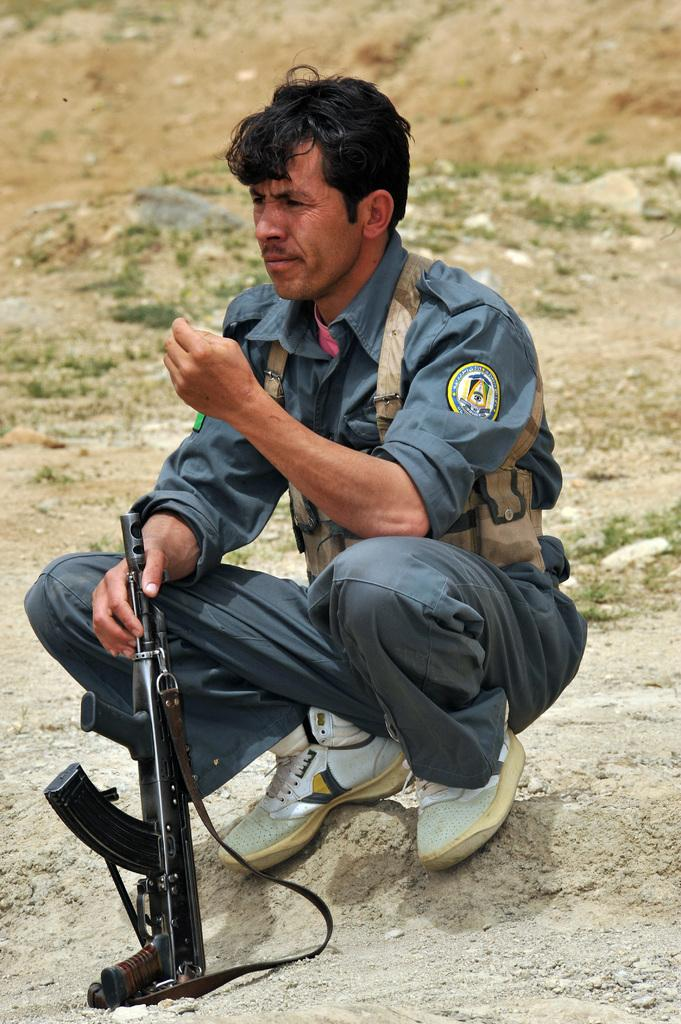What is the position of the man in the image? The man is sitting on his knees in the image. What is the man holding in the image? The man is holding a gun in the image. What can be seen in the background of the image? There is a ground visible in the background of the image. What type of shoe is the man wearing in the image? There is no information about the man's shoes in the image, so we cannot determine what type of shoe he is wearing. 